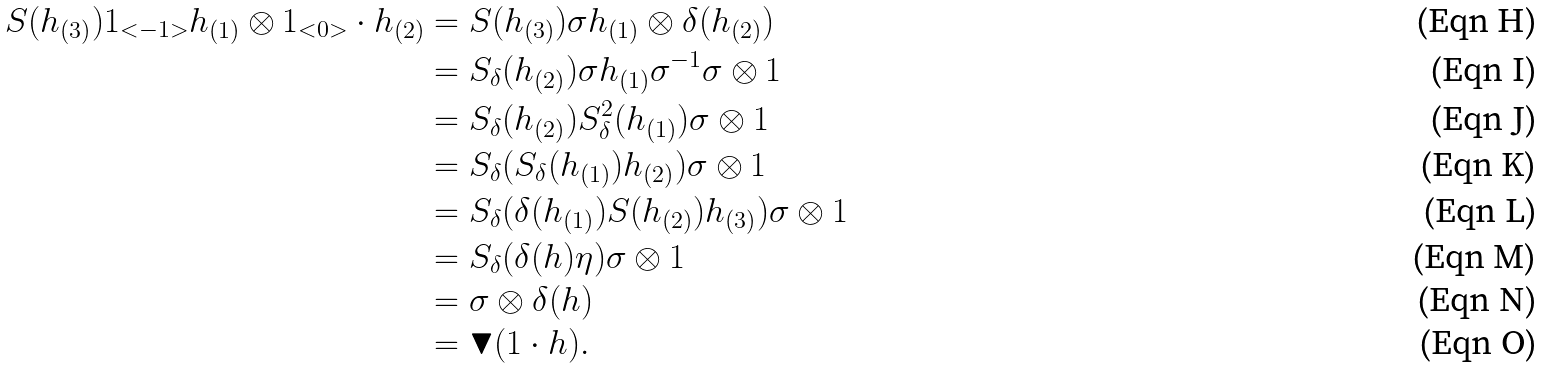<formula> <loc_0><loc_0><loc_500><loc_500>S ( h _ { ( 3 ) } ) 1 _ { < - 1 > } h _ { ( 1 ) } \otimes 1 _ { < 0 > } \cdot h _ { ( 2 ) } & = S ( h _ { ( 3 ) } ) \sigma h _ { ( 1 ) } \otimes \delta ( h _ { ( 2 ) } ) \\ & = S _ { \delta } ( h _ { ( 2 ) } ) \sigma h _ { ( 1 ) } \sigma ^ { - 1 } \sigma \otimes 1 \\ & = S _ { \delta } ( h _ { ( 2 ) } ) S _ { \delta } ^ { 2 } ( h _ { ( 1 ) } ) \sigma \otimes 1 \\ & = S _ { \delta } ( S _ { \delta } ( h _ { ( 1 ) } ) h _ { ( 2 ) } ) \sigma \otimes 1 \\ & = S _ { \delta } ( \delta ( h _ { ( 1 ) } ) S ( h _ { ( 2 ) } ) h _ { ( 3 ) } ) \sigma \otimes 1 \\ & = S _ { \delta } ( \delta ( h ) \eta ) \sigma \otimes 1 \\ & = \sigma \otimes \delta ( h ) \\ & = \blacktriangledown ( 1 \cdot h ) .</formula> 